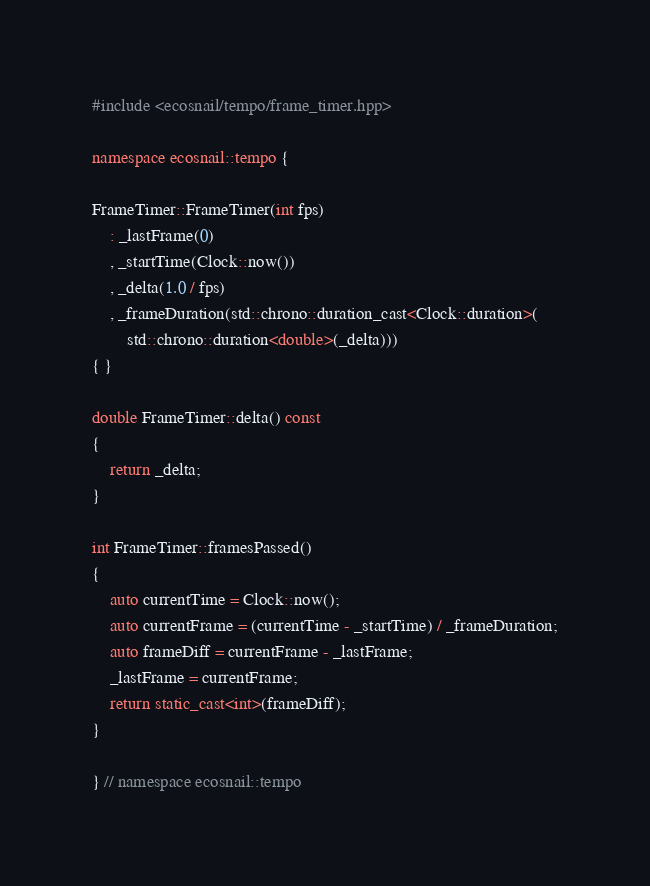<code> <loc_0><loc_0><loc_500><loc_500><_C++_>#include <ecosnail/tempo/frame_timer.hpp>

namespace ecosnail::tempo {

FrameTimer::FrameTimer(int fps)
    : _lastFrame(0)
    , _startTime(Clock::now())
    , _delta(1.0 / fps)
    , _frameDuration(std::chrono::duration_cast<Clock::duration>(
        std::chrono::duration<double>(_delta)))
{ }

double FrameTimer::delta() const
{
    return _delta;
}

int FrameTimer::framesPassed()
{
    auto currentTime = Clock::now();
    auto currentFrame = (currentTime - _startTime) / _frameDuration;
    auto frameDiff = currentFrame - _lastFrame;
    _lastFrame = currentFrame;
    return static_cast<int>(frameDiff);
}

} // namespace ecosnail::tempo
</code> 